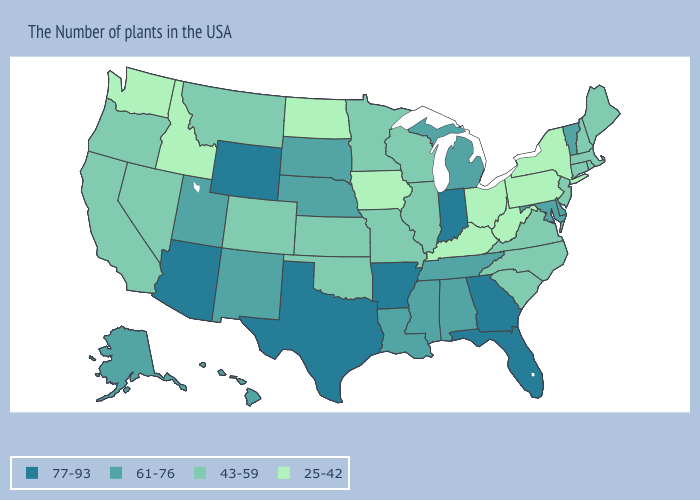Does Utah have a lower value than Indiana?
Concise answer only. Yes. Does South Carolina have a lower value than Texas?
Concise answer only. Yes. What is the value of New York?
Write a very short answer. 25-42. Name the states that have a value in the range 43-59?
Short answer required. Maine, Massachusetts, Rhode Island, New Hampshire, Connecticut, New Jersey, Virginia, North Carolina, South Carolina, Wisconsin, Illinois, Missouri, Minnesota, Kansas, Oklahoma, Colorado, Montana, Nevada, California, Oregon. What is the lowest value in the USA?
Short answer required. 25-42. What is the value of Montana?
Give a very brief answer. 43-59. Does Oregon have the lowest value in the West?
Quick response, please. No. What is the value of Maine?
Concise answer only. 43-59. Name the states that have a value in the range 25-42?
Write a very short answer. New York, Pennsylvania, West Virginia, Ohio, Kentucky, Iowa, North Dakota, Idaho, Washington. What is the highest value in the USA?
Keep it brief. 77-93. What is the value of North Carolina?
Give a very brief answer. 43-59. Name the states that have a value in the range 43-59?
Keep it brief. Maine, Massachusetts, Rhode Island, New Hampshire, Connecticut, New Jersey, Virginia, North Carolina, South Carolina, Wisconsin, Illinois, Missouri, Minnesota, Kansas, Oklahoma, Colorado, Montana, Nevada, California, Oregon. Name the states that have a value in the range 77-93?
Write a very short answer. Florida, Georgia, Indiana, Arkansas, Texas, Wyoming, Arizona. Does New Mexico have a lower value than Oregon?
Answer briefly. No. How many symbols are there in the legend?
Quick response, please. 4. 